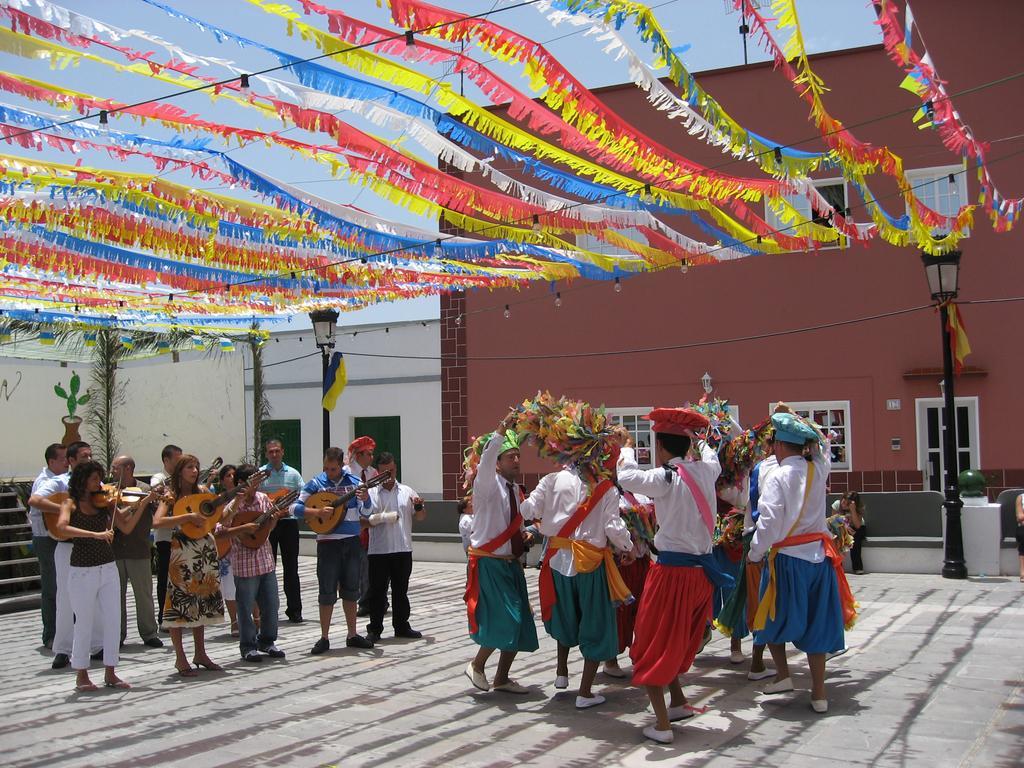Describe this image in one or two sentences. In this image we can see there are a few people dancing and a few people playing musical instruments. And there is the wall with windows and painting and there are light poles, stairs, flags and the sky. 